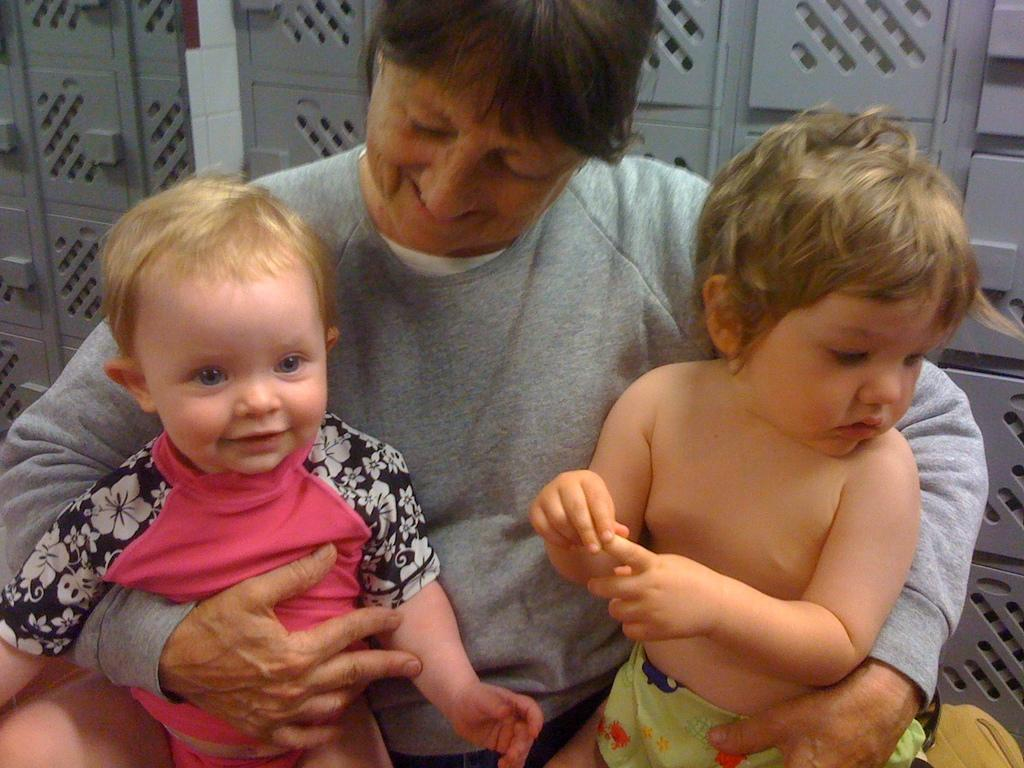Who is the main subject in the image? There is a woman in the image. What is the woman doing in the image? The woman is sitting. What is the woman holding in the image? The woman is holding two babies. What can be seen in the background of the image? There are cupboards in the background of the image. What type of desk can be seen in the image? There is no desk present in the image. What color is the marble on the floor in the image? There is no marble floor present in the image. 